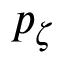Convert formula to latex. <formula><loc_0><loc_0><loc_500><loc_500>p _ { \zeta }</formula> 